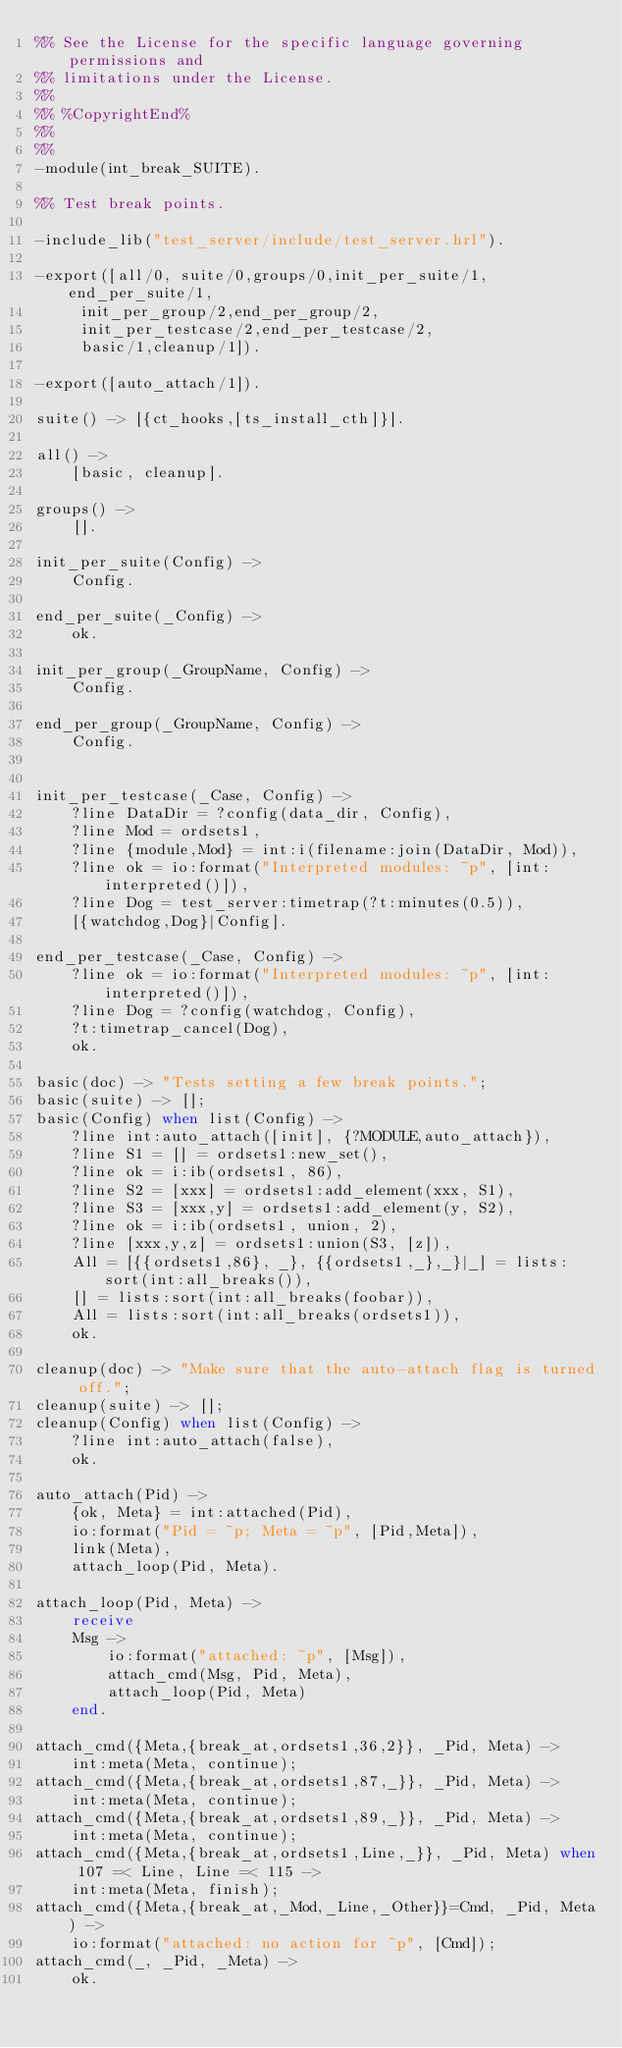<code> <loc_0><loc_0><loc_500><loc_500><_Erlang_>%% See the License for the specific language governing permissions and
%% limitations under the License.
%%
%% %CopyrightEnd%
%%
%%
-module(int_break_SUITE).

%% Test break points.

-include_lib("test_server/include/test_server.hrl").

-export([all/0, suite/0,groups/0,init_per_suite/1, end_per_suite/1, 
	 init_per_group/2,end_per_group/2,
	 init_per_testcase/2,end_per_testcase/2,
	 basic/1,cleanup/1]).

-export([auto_attach/1]).

suite() -> [{ct_hooks,[ts_install_cth]}].

all() -> 
    [basic, cleanup].

groups() -> 
    [].

init_per_suite(Config) ->
    Config.

end_per_suite(_Config) ->
    ok.

init_per_group(_GroupName, Config) ->
    Config.

end_per_group(_GroupName, Config) ->
    Config.


init_per_testcase(_Case, Config) ->
    ?line DataDir = ?config(data_dir, Config),
    ?line Mod = ordsets1,
    ?line {module,Mod} = int:i(filename:join(DataDir, Mod)),
    ?line ok = io:format("Interpreted modules: ~p", [int:interpreted()]),
    ?line Dog = test_server:timetrap(?t:minutes(0.5)),
    [{watchdog,Dog}|Config].

end_per_testcase(_Case, Config) ->
    ?line ok = io:format("Interpreted modules: ~p", [int:interpreted()]),
    ?line Dog = ?config(watchdog, Config),
    ?t:timetrap_cancel(Dog),
    ok.

basic(doc) -> "Tests setting a few break points.";
basic(suite) -> [];
basic(Config) when list(Config) ->
    ?line int:auto_attach([init], {?MODULE,auto_attach}),
    ?line S1 = [] = ordsets1:new_set(),
    ?line ok = i:ib(ordsets1, 86),
    ?line S2 = [xxx] = ordsets1:add_element(xxx, S1),
    ?line S3 = [xxx,y] = ordsets1:add_element(y, S2),
    ?line ok = i:ib(ordsets1, union, 2),
    ?line [xxx,y,z] = ordsets1:union(S3, [z]),
    All = [{{ordsets1,86}, _}, {{ordsets1,_},_}|_] = lists:sort(int:all_breaks()),
    [] = lists:sort(int:all_breaks(foobar)),
    All = lists:sort(int:all_breaks(ordsets1)),
    ok.

cleanup(doc) -> "Make sure that the auto-attach flag is turned off.";
cleanup(suite) -> [];
cleanup(Config) when list(Config) ->
    ?line int:auto_attach(false),
    ok.

auto_attach(Pid) ->
    {ok, Meta} = int:attached(Pid),
    io:format("Pid = ~p; Meta = ~p", [Pid,Meta]),
    link(Meta),
    attach_loop(Pid, Meta).

attach_loop(Pid, Meta) ->
    receive
	Msg ->
	    io:format("attached: ~p", [Msg]),
	    attach_cmd(Msg, Pid, Meta),
	    attach_loop(Pid, Meta)
    end.

attach_cmd({Meta,{break_at,ordsets1,36,2}}, _Pid, Meta) ->
    int:meta(Meta, continue);
attach_cmd({Meta,{break_at,ordsets1,87,_}}, _Pid, Meta) ->
    int:meta(Meta, continue);
attach_cmd({Meta,{break_at,ordsets1,89,_}}, _Pid, Meta) ->
    int:meta(Meta, continue);
attach_cmd({Meta,{break_at,ordsets1,Line,_}}, _Pid, Meta) when 107 =< Line, Line =< 115 ->
    int:meta(Meta, finish);
attach_cmd({Meta,{break_at,_Mod,_Line,_Other}}=Cmd, _Pid, Meta) ->
    io:format("attached: no action for ~p", [Cmd]);
attach_cmd(_, _Pid, _Meta) ->
    ok.
</code> 